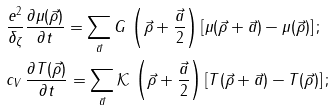Convert formula to latex. <formula><loc_0><loc_0><loc_500><loc_500>& \frac { e ^ { 2 } } { \delta _ { \zeta } } \frac { \partial \mu ( \vec { \rho } ) } { \partial t } = \sum _ { \vec { a } } G \, \left ( \vec { \rho } + \frac { \vec { a } } { 2 } \right ) \left [ \mu ( \vec { \rho } + \vec { a } ) - \mu ( \vec { \rho } ) \right ] ; \\ & c _ { V } \, \frac { \partial T ( \vec { \rho } ) } { \partial t } = \sum _ { \vec { a } } \mathcal { K } \, \left ( \vec { \rho } + \frac { \vec { a } } { 2 } \right ) \left [ T ( \vec { \rho } + \vec { a } ) - T ( \vec { \rho } ) \right ] ;</formula> 